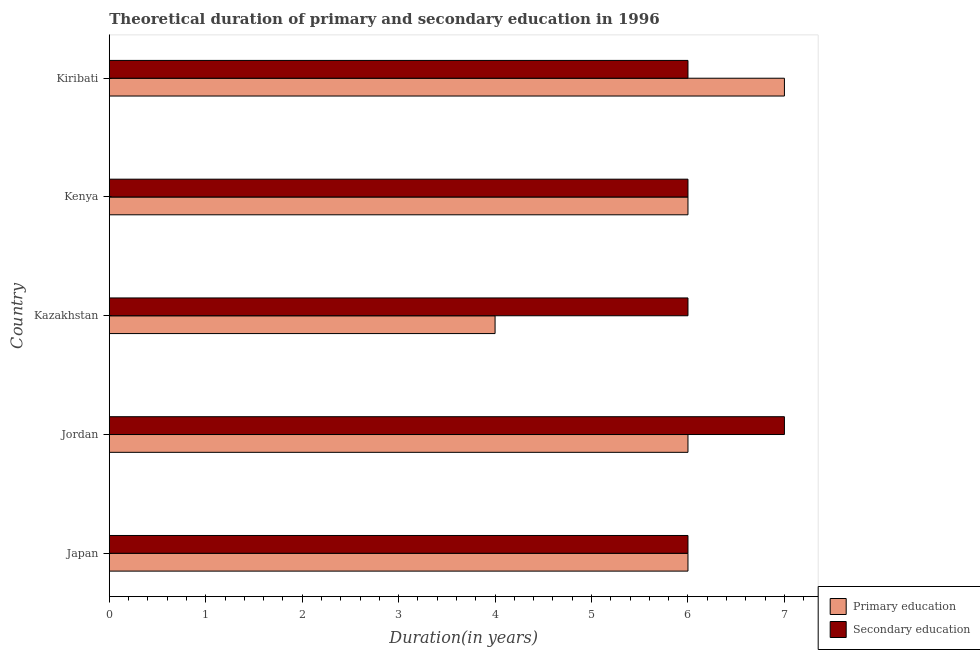How many different coloured bars are there?
Your answer should be very brief. 2. How many bars are there on the 1st tick from the top?
Your answer should be compact. 2. How many bars are there on the 4th tick from the bottom?
Make the answer very short. 2. In how many cases, is the number of bars for a given country not equal to the number of legend labels?
Provide a short and direct response. 0. What is the duration of primary education in Jordan?
Your answer should be compact. 6. Across all countries, what is the maximum duration of secondary education?
Provide a short and direct response. 7. In which country was the duration of primary education maximum?
Ensure brevity in your answer.  Kiribati. What is the total duration of secondary education in the graph?
Make the answer very short. 31. What is the difference between the duration of primary education in Japan and that in Kiribati?
Ensure brevity in your answer.  -1. What is the difference between the duration of primary education and duration of secondary education in Kazakhstan?
Your answer should be compact. -2. What is the ratio of the duration of primary education in Kazakhstan to that in Kenya?
Provide a succinct answer. 0.67. What is the difference between the highest and the lowest duration of secondary education?
Your response must be concise. 1. Is the sum of the duration of secondary education in Kenya and Kiribati greater than the maximum duration of primary education across all countries?
Your answer should be compact. Yes. What does the 2nd bar from the bottom in Japan represents?
Make the answer very short. Secondary education. How many bars are there?
Your response must be concise. 10. How many countries are there in the graph?
Provide a short and direct response. 5. Are the values on the major ticks of X-axis written in scientific E-notation?
Keep it short and to the point. No. How are the legend labels stacked?
Your response must be concise. Vertical. What is the title of the graph?
Your response must be concise. Theoretical duration of primary and secondary education in 1996. Does "Exports" appear as one of the legend labels in the graph?
Your answer should be compact. No. What is the label or title of the X-axis?
Your answer should be very brief. Duration(in years). What is the label or title of the Y-axis?
Give a very brief answer. Country. What is the Duration(in years) of Secondary education in Japan?
Make the answer very short. 6. What is the Duration(in years) of Primary education in Jordan?
Keep it short and to the point. 6. What is the Duration(in years) of Secondary education in Jordan?
Your answer should be very brief. 7. What is the Duration(in years) in Primary education in Kazakhstan?
Offer a terse response. 4. What is the Duration(in years) of Secondary education in Kazakhstan?
Offer a terse response. 6. What is the Duration(in years) in Secondary education in Kenya?
Your response must be concise. 6. What is the Duration(in years) of Primary education in Kiribati?
Make the answer very short. 7. Across all countries, what is the maximum Duration(in years) in Secondary education?
Make the answer very short. 7. Across all countries, what is the minimum Duration(in years) in Primary education?
Your response must be concise. 4. What is the total Duration(in years) in Primary education in the graph?
Ensure brevity in your answer.  29. What is the difference between the Duration(in years) in Primary education in Japan and that in Jordan?
Your response must be concise. 0. What is the difference between the Duration(in years) in Secondary education in Japan and that in Jordan?
Your answer should be very brief. -1. What is the difference between the Duration(in years) in Secondary education in Japan and that in Kiribati?
Ensure brevity in your answer.  0. What is the difference between the Duration(in years) in Secondary education in Jordan and that in Kenya?
Your answer should be compact. 1. What is the difference between the Duration(in years) in Secondary education in Jordan and that in Kiribati?
Your answer should be very brief. 1. What is the difference between the Duration(in years) of Primary education in Kazakhstan and that in Kenya?
Keep it short and to the point. -2. What is the difference between the Duration(in years) of Primary education in Kazakhstan and that in Kiribati?
Your response must be concise. -3. What is the difference between the Duration(in years) of Secondary education in Kenya and that in Kiribati?
Provide a short and direct response. 0. What is the difference between the Duration(in years) in Primary education in Japan and the Duration(in years) in Secondary education in Kiribati?
Your answer should be very brief. 0. What is the difference between the Duration(in years) in Primary education in Jordan and the Duration(in years) in Secondary education in Kenya?
Keep it short and to the point. 0. What is the difference between the Duration(in years) in Primary education in Jordan and the Duration(in years) in Secondary education in Kiribati?
Make the answer very short. 0. What is the difference between the Duration(in years) of Primary education in Kazakhstan and the Duration(in years) of Secondary education in Kenya?
Offer a terse response. -2. What is the difference between the Duration(in years) of Primary education in Kenya and the Duration(in years) of Secondary education in Kiribati?
Provide a short and direct response. 0. What is the average Duration(in years) in Primary education per country?
Offer a terse response. 5.8. What is the difference between the Duration(in years) of Primary education and Duration(in years) of Secondary education in Japan?
Offer a very short reply. 0. What is the difference between the Duration(in years) in Primary education and Duration(in years) in Secondary education in Kenya?
Provide a succinct answer. 0. What is the ratio of the Duration(in years) in Primary education in Japan to that in Jordan?
Give a very brief answer. 1. What is the ratio of the Duration(in years) of Secondary education in Japan to that in Kazakhstan?
Your answer should be very brief. 1. What is the ratio of the Duration(in years) in Secondary education in Japan to that in Kenya?
Offer a terse response. 1. What is the ratio of the Duration(in years) of Primary education in Japan to that in Kiribati?
Your response must be concise. 0.86. What is the ratio of the Duration(in years) in Secondary education in Japan to that in Kiribati?
Your response must be concise. 1. What is the ratio of the Duration(in years) of Primary education in Jordan to that in Kazakhstan?
Ensure brevity in your answer.  1.5. What is the ratio of the Duration(in years) in Primary education in Jordan to that in Kenya?
Provide a succinct answer. 1. What is the ratio of the Duration(in years) in Secondary education in Jordan to that in Kenya?
Your answer should be very brief. 1.17. What is the ratio of the Duration(in years) of Primary education in Jordan to that in Kiribati?
Make the answer very short. 0.86. What is the ratio of the Duration(in years) of Secondary education in Jordan to that in Kiribati?
Provide a succinct answer. 1.17. What is the ratio of the Duration(in years) in Primary education in Kazakhstan to that in Kiribati?
Your answer should be compact. 0.57. What is the ratio of the Duration(in years) of Secondary education in Kazakhstan to that in Kiribati?
Provide a succinct answer. 1. What is the ratio of the Duration(in years) in Primary education in Kenya to that in Kiribati?
Offer a very short reply. 0.86. What is the difference between the highest and the second highest Duration(in years) of Primary education?
Provide a short and direct response. 1. 